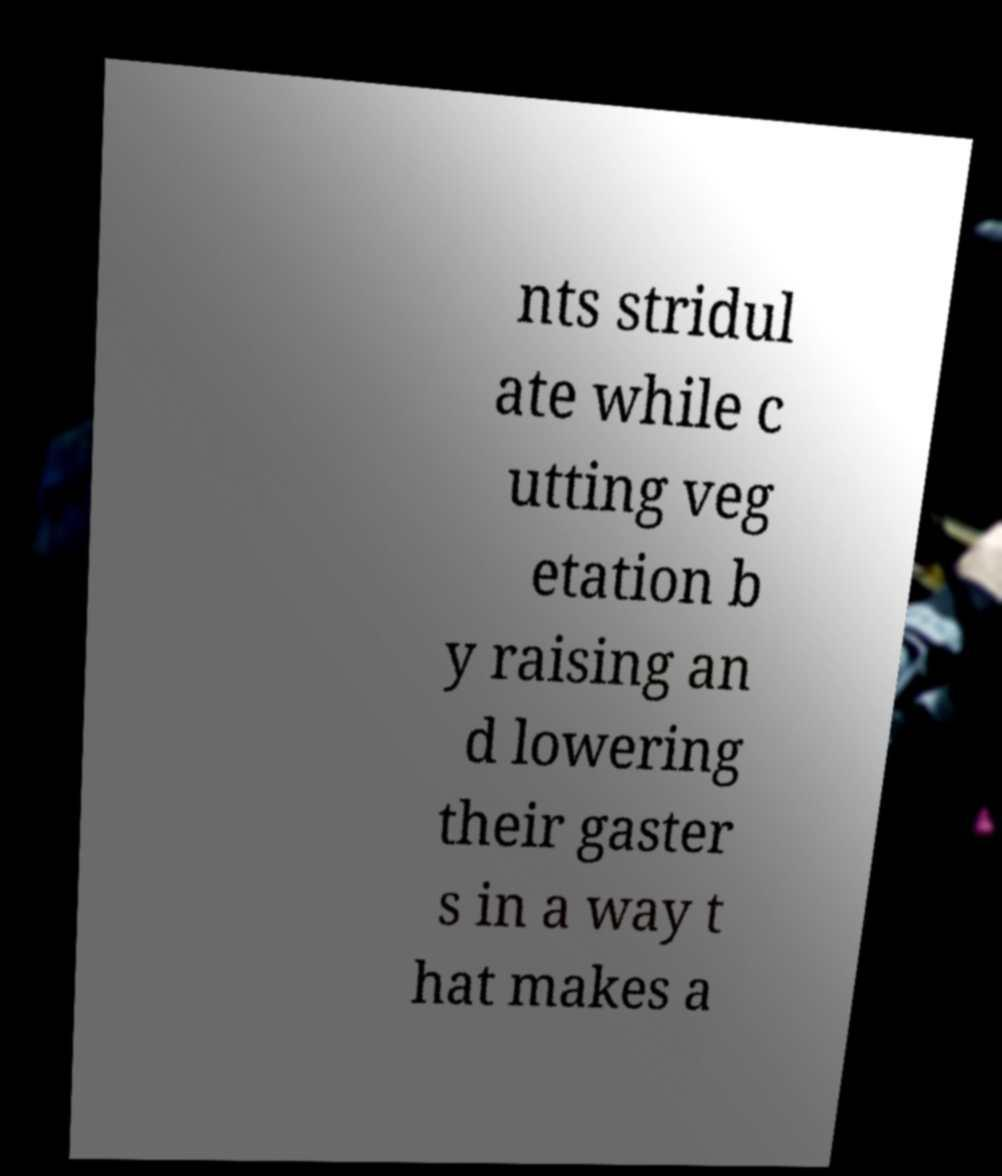Can you accurately transcribe the text from the provided image for me? nts stridul ate while c utting veg etation b y raising an d lowering their gaster s in a way t hat makes a 